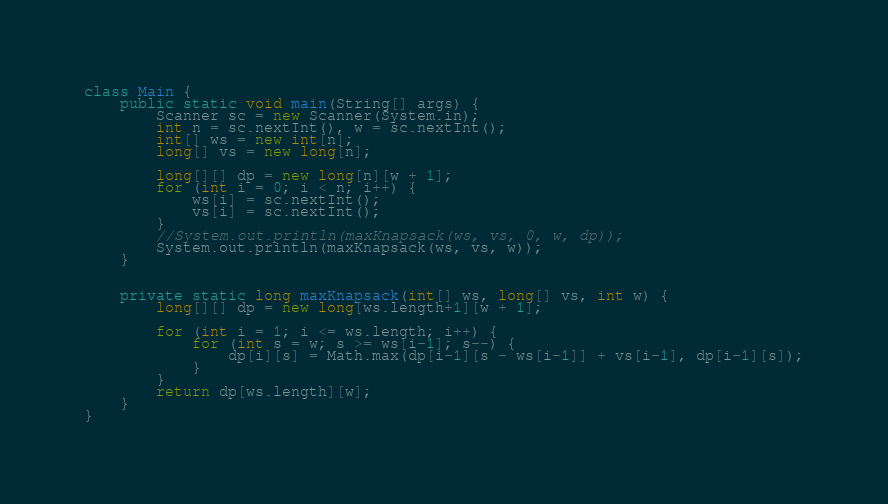Convert code to text. <code><loc_0><loc_0><loc_500><loc_500><_Java_>class Main {
    public static void main(String[] args) {
        Scanner sc = new Scanner(System.in);
        int n = sc.nextInt(), w = sc.nextInt();
        int[] ws = new int[n];
        long[] vs = new long[n];

        long[][] dp = new long[n][w + 1];
        for (int i = 0; i < n; i++) {
            ws[i] = sc.nextInt();
            vs[i] = sc.nextInt();
        }
        //System.out.println(maxKnapsack(ws, vs, 0, w, dp));
        System.out.println(maxKnapsack(ws, vs, w));
    }


    private static long maxKnapsack(int[] ws, long[] vs, int w) {
        long[][] dp = new long[ws.length+1][w + 1];

        for (int i = 1; i <= ws.length; i++) {
            for (int s = w; s >= ws[i-1]; s--) {
                dp[i][s] = Math.max(dp[i-1][s - ws[i-1]] + vs[i-1], dp[i-1][s]);
            }
        }
        return dp[ws.length][w];
    }
}

</code> 